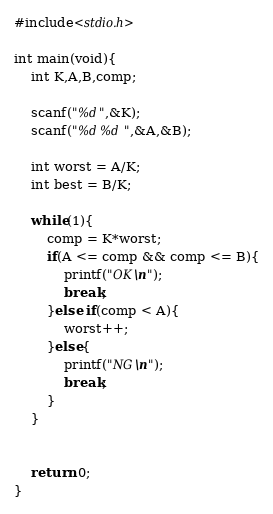<code> <loc_0><loc_0><loc_500><loc_500><_C_>#include<stdio.h>

int main(void){
	int K,A,B,comp;
	
	scanf("%d",&K);
	scanf("%d %d",&A,&B);
	
	int worst = A/K;
	int best = B/K;
	
	while(1){
		comp = K*worst;
		if(A <= comp && comp <= B){
			printf("OK\n");
			break;
		}else if(comp < A){
			worst++;
		}else{
			printf("NG\n");
			break;
		}
	}
	
	
	return 0;
}</code> 